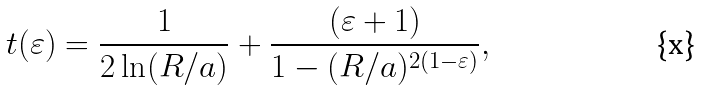<formula> <loc_0><loc_0><loc_500><loc_500>t ( \varepsilon ) = \frac { 1 } { 2 \ln ( R / a ) } + \frac { ( \varepsilon + 1 ) } { 1 - ( R / a ) ^ { 2 ( 1 - \varepsilon ) } } ,</formula> 